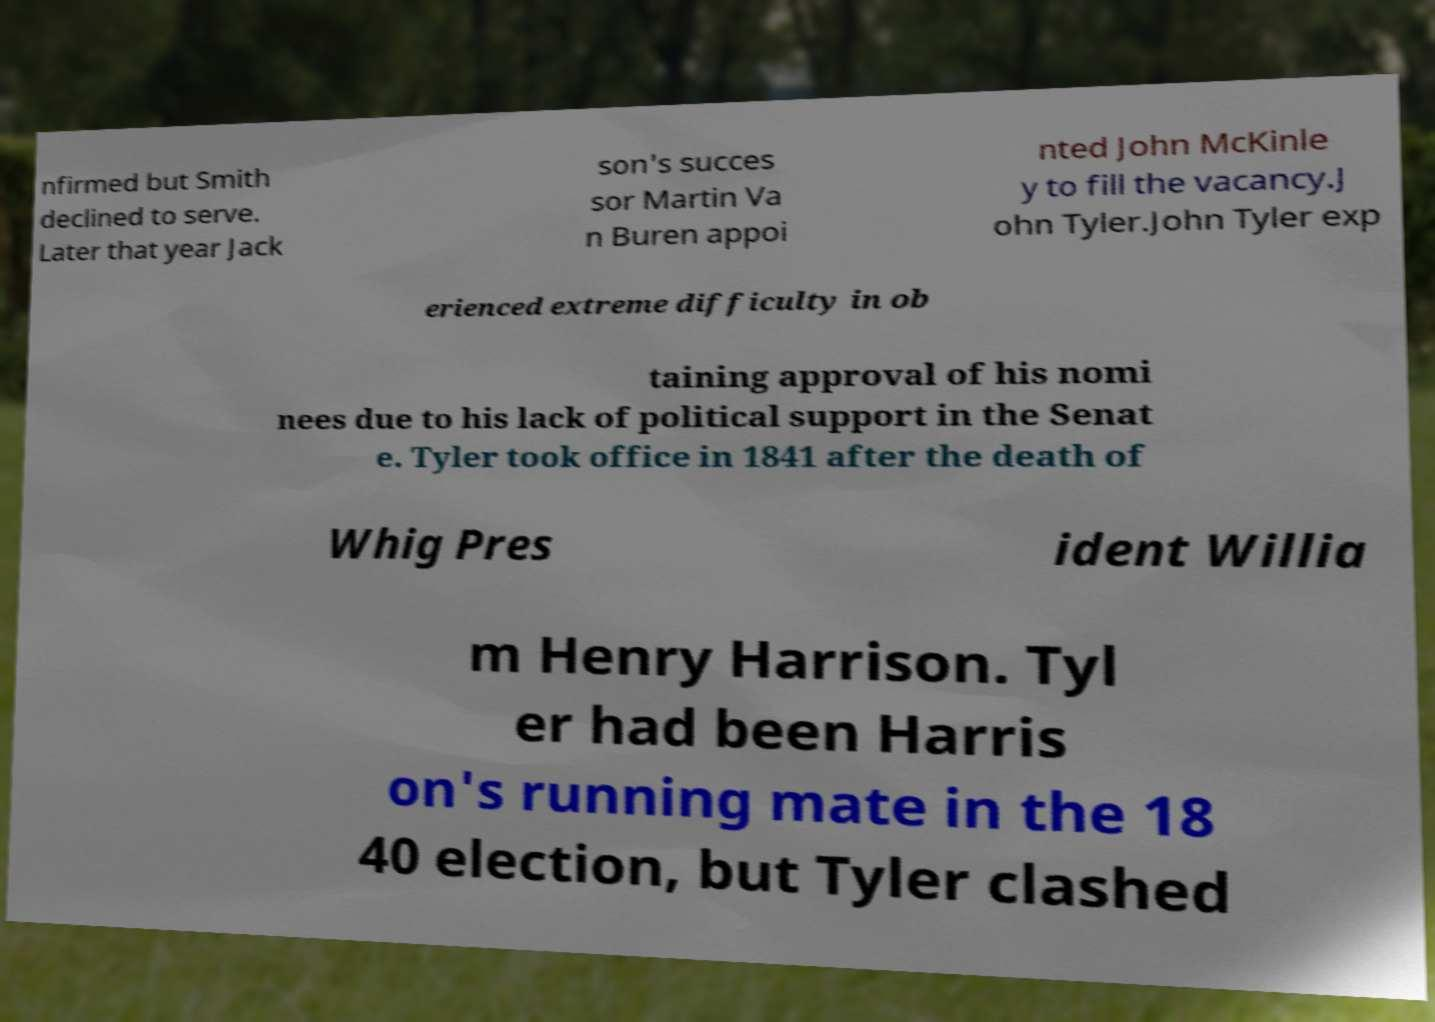What messages or text are displayed in this image? I need them in a readable, typed format. nfirmed but Smith declined to serve. Later that year Jack son's succes sor Martin Va n Buren appoi nted John McKinle y to fill the vacancy.J ohn Tyler.John Tyler exp erienced extreme difficulty in ob taining approval of his nomi nees due to his lack of political support in the Senat e. Tyler took office in 1841 after the death of Whig Pres ident Willia m Henry Harrison. Tyl er had been Harris on's running mate in the 18 40 election, but Tyler clashed 